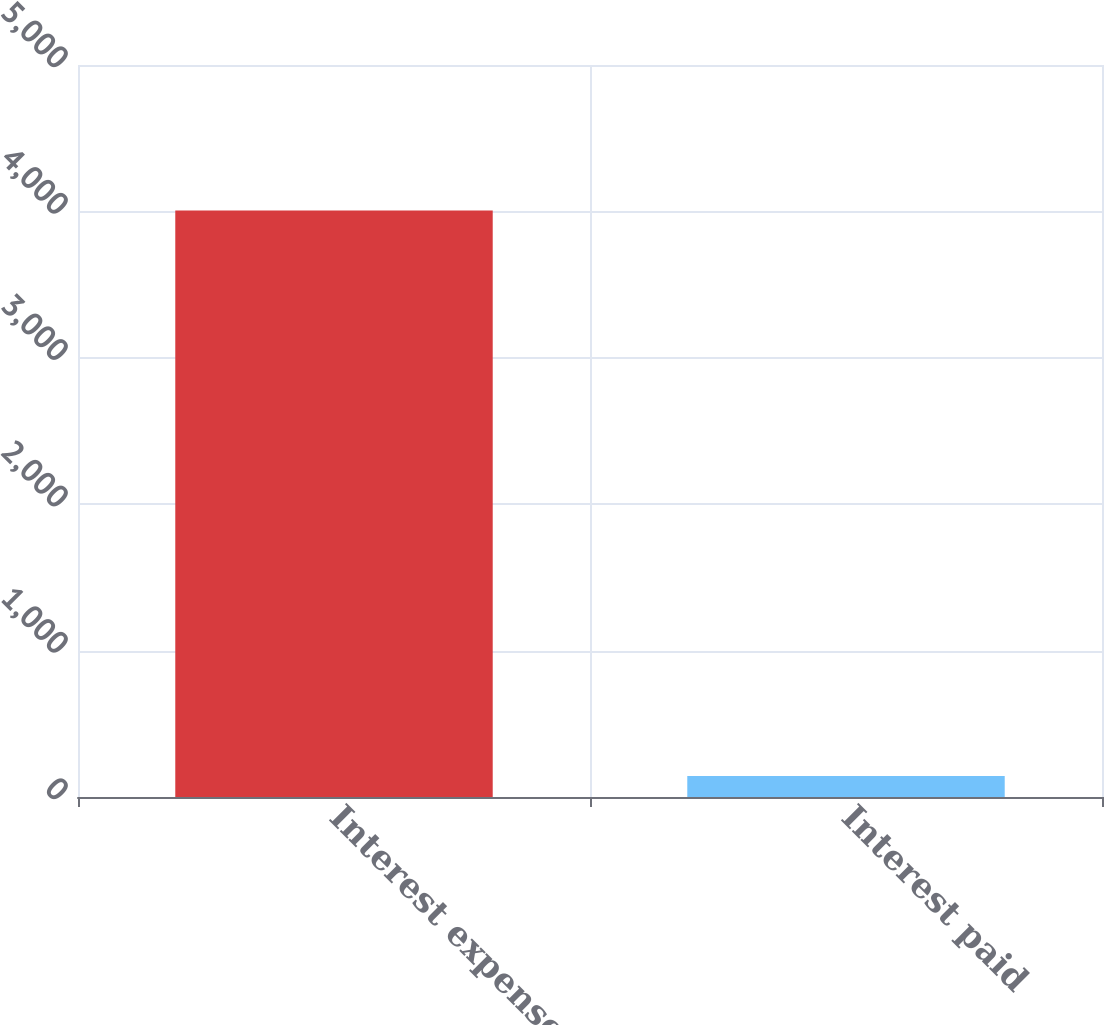<chart> <loc_0><loc_0><loc_500><loc_500><bar_chart><fcel>Interest expense<fcel>Interest paid<nl><fcel>4006<fcel>144<nl></chart> 